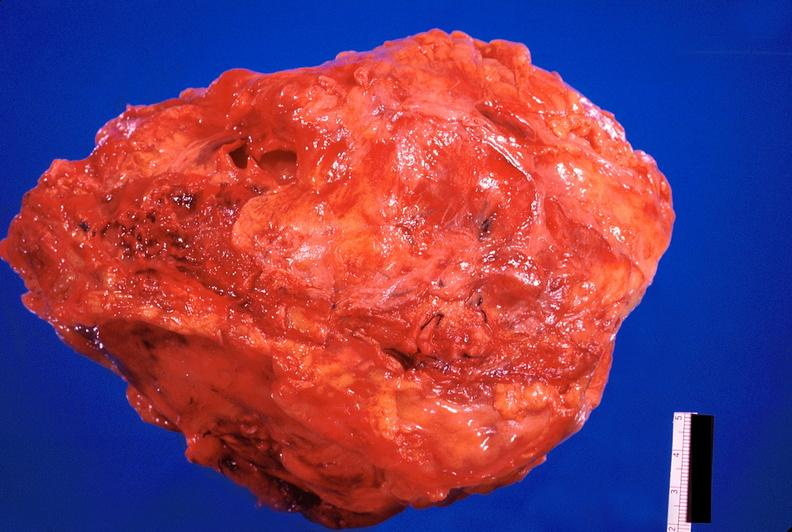s metastatic carcinoma present?
Answer the question using a single word or phrase. No 